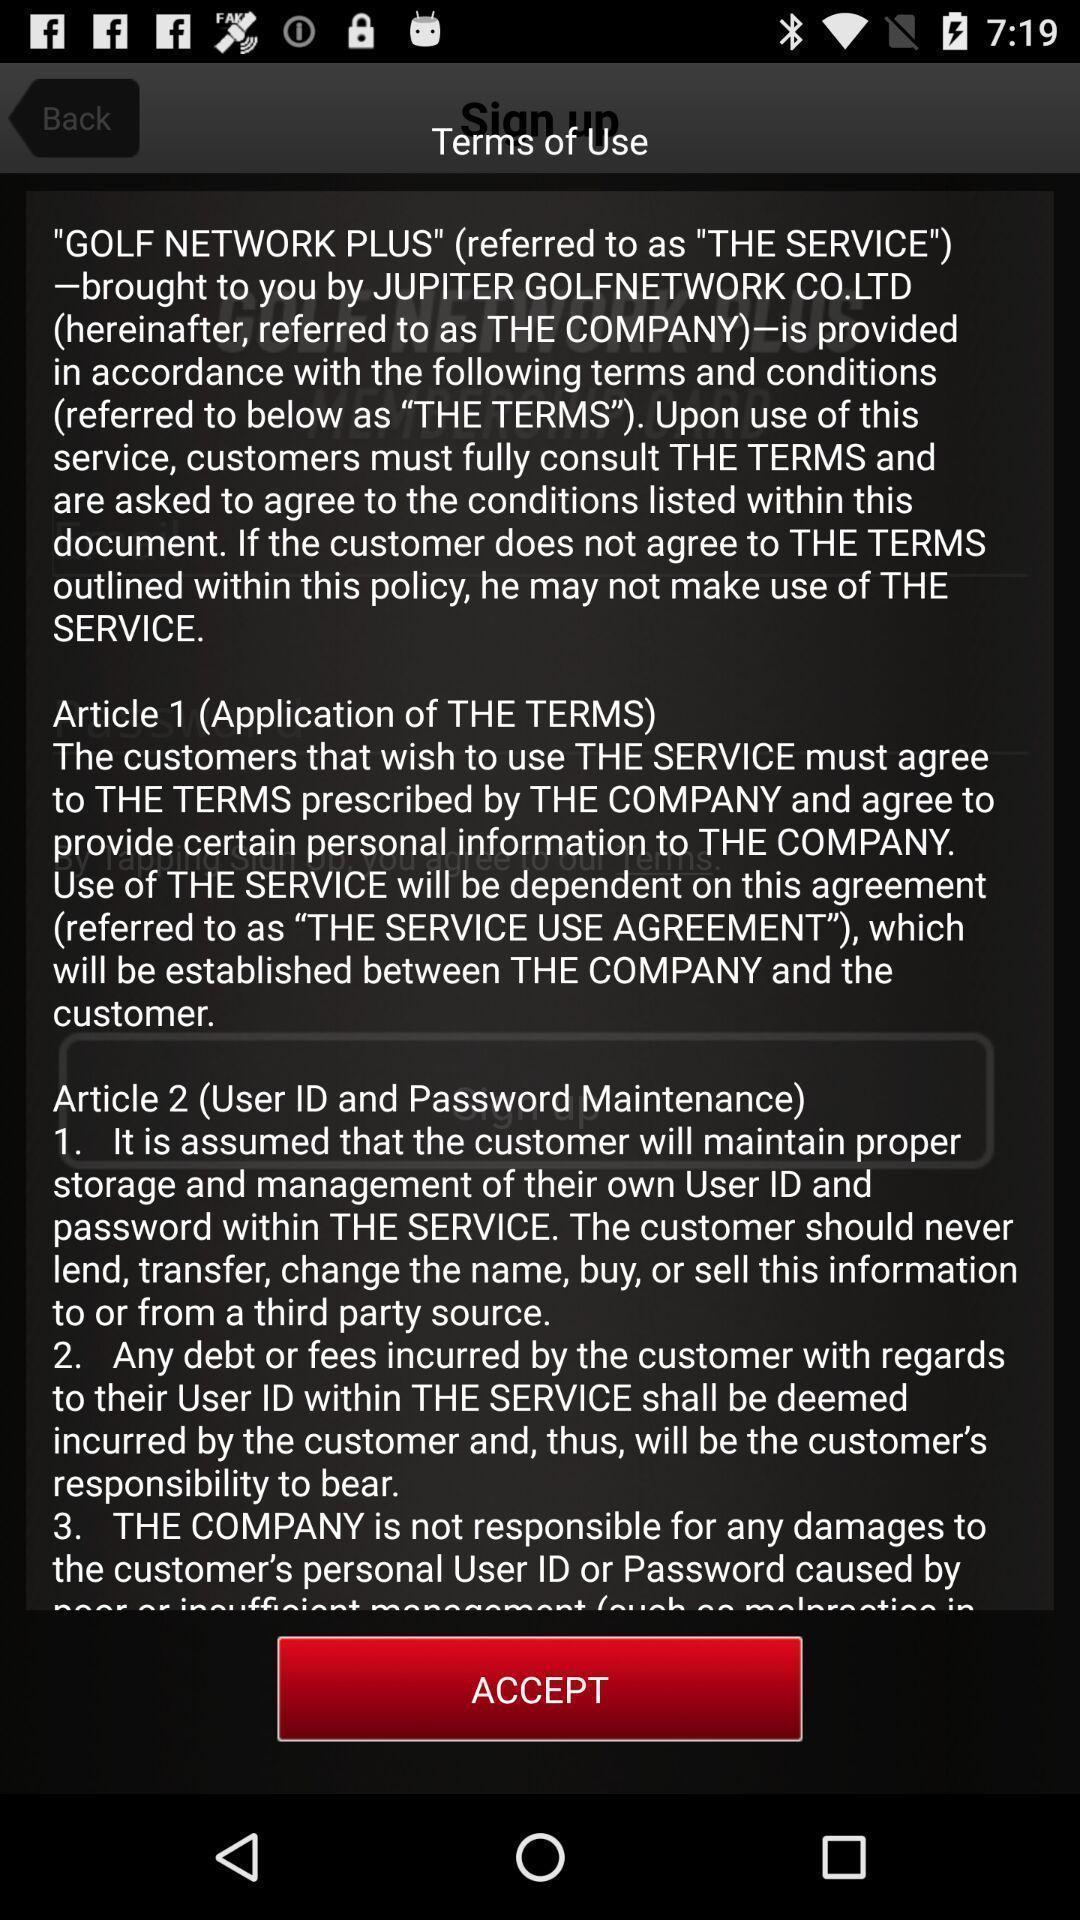Give me a narrative description of this picture. Screen shows to accept terms and conditions. 